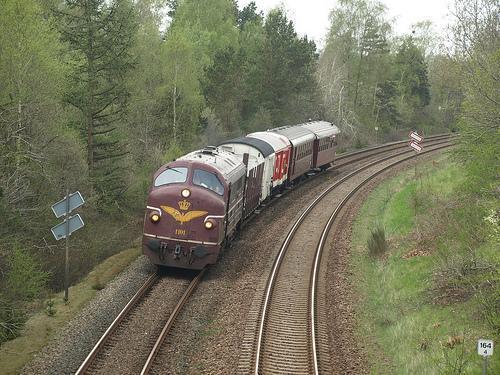How many cars are on the train?
Give a very brief answer. 6. 